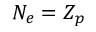<formula> <loc_0><loc_0><loc_500><loc_500>N _ { e } = Z _ { p }</formula> 